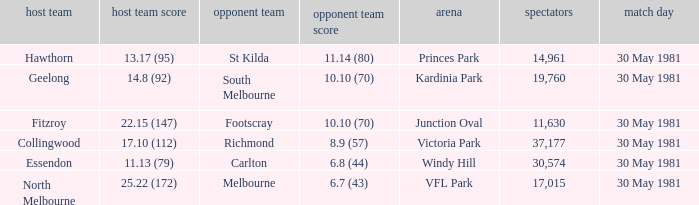What is the home venue of essendon with a crowd larger than 19,760? Windy Hill. 